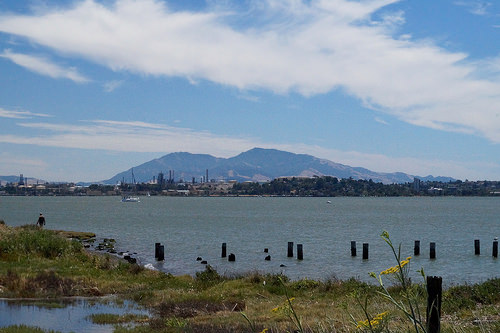<image>
Is there a mountain next to the plant? No. The mountain is not positioned next to the plant. They are located in different areas of the scene. 